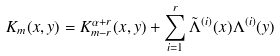<formula> <loc_0><loc_0><loc_500><loc_500>K _ { m } ( x , y ) = K _ { m - r } ^ { \alpha + r } ( x , y ) + \sum _ { i = 1 } ^ { r } \tilde { \Lambda } ^ { ( i ) } ( x ) \Lambda ^ { ( i ) } ( y )</formula> 